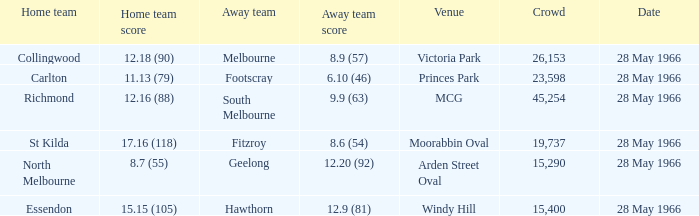Which Venue has a Home team of essendon? Windy Hill. 